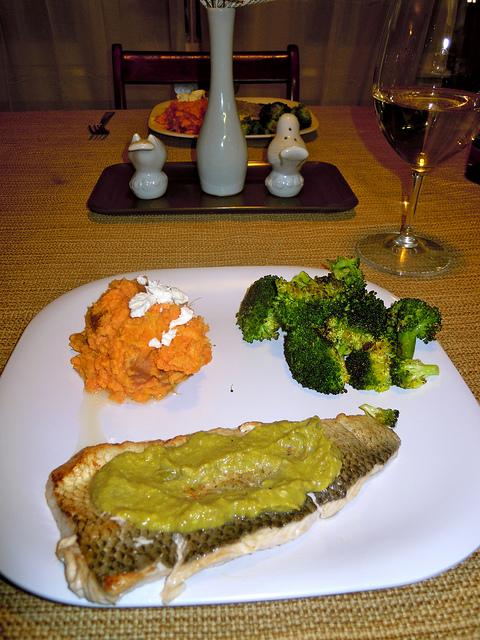What type of wine is in the glass?
Give a very brief answer. White. What is the vegetable on the right?
Give a very brief answer. Broccoli. What color is the plate?
Write a very short answer. White. 